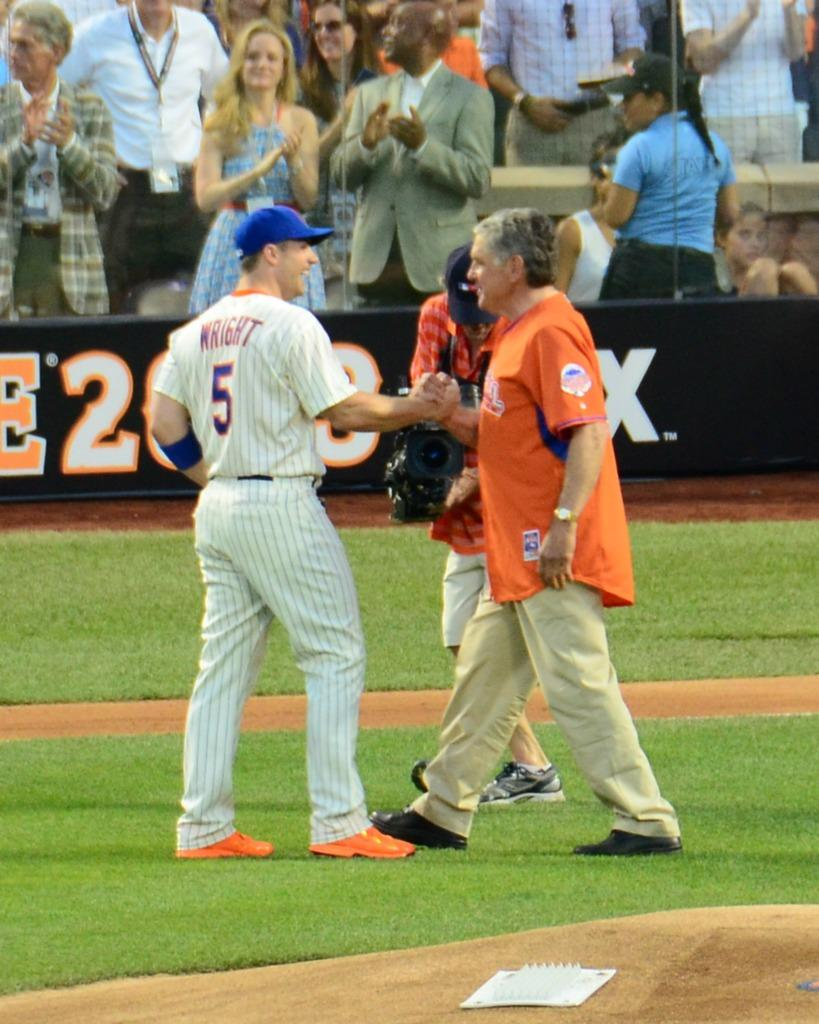<image>
Summarize the visual content of the image. David Wright shaking the hand of another person 